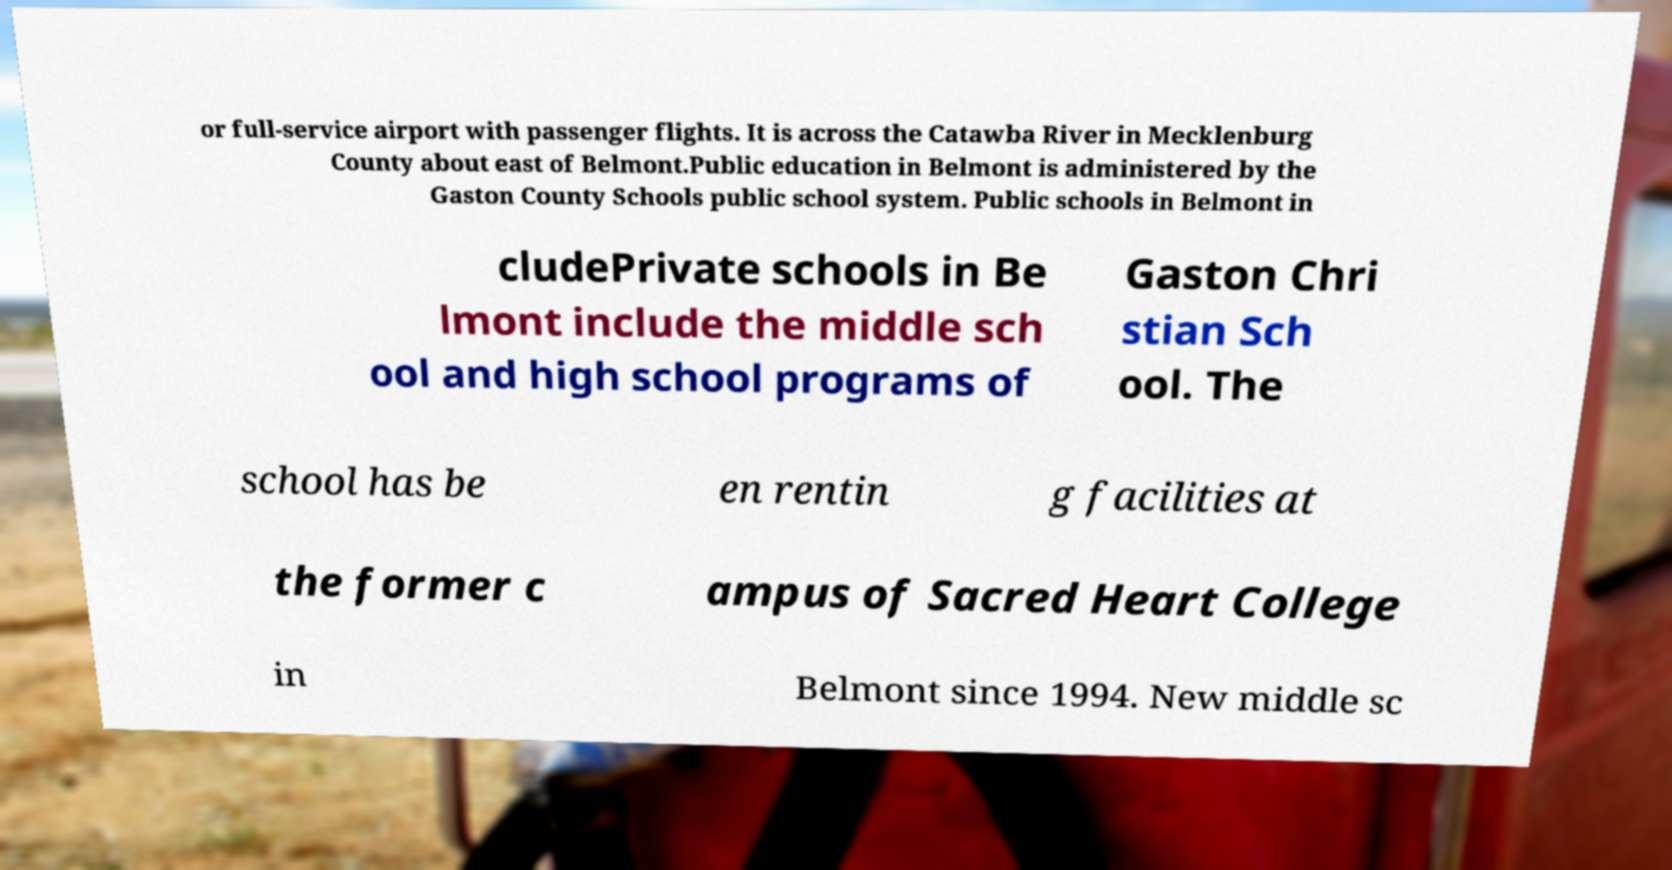There's text embedded in this image that I need extracted. Can you transcribe it verbatim? or full-service airport with passenger flights. It is across the Catawba River in Mecklenburg County about east of Belmont.Public education in Belmont is administered by the Gaston County Schools public school system. Public schools in Belmont in cludePrivate schools in Be lmont include the middle sch ool and high school programs of Gaston Chri stian Sch ool. The school has be en rentin g facilities at the former c ampus of Sacred Heart College in Belmont since 1994. New middle sc 